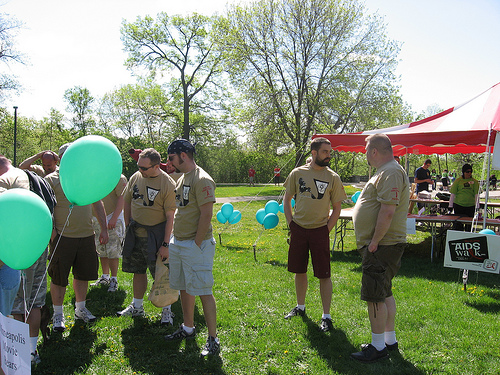<image>
Can you confirm if the ballon is on the string? Yes. Looking at the image, I can see the ballon is positioned on top of the string, with the string providing support. Is the poster under the tree? No. The poster is not positioned under the tree. The vertical relationship between these objects is different. 